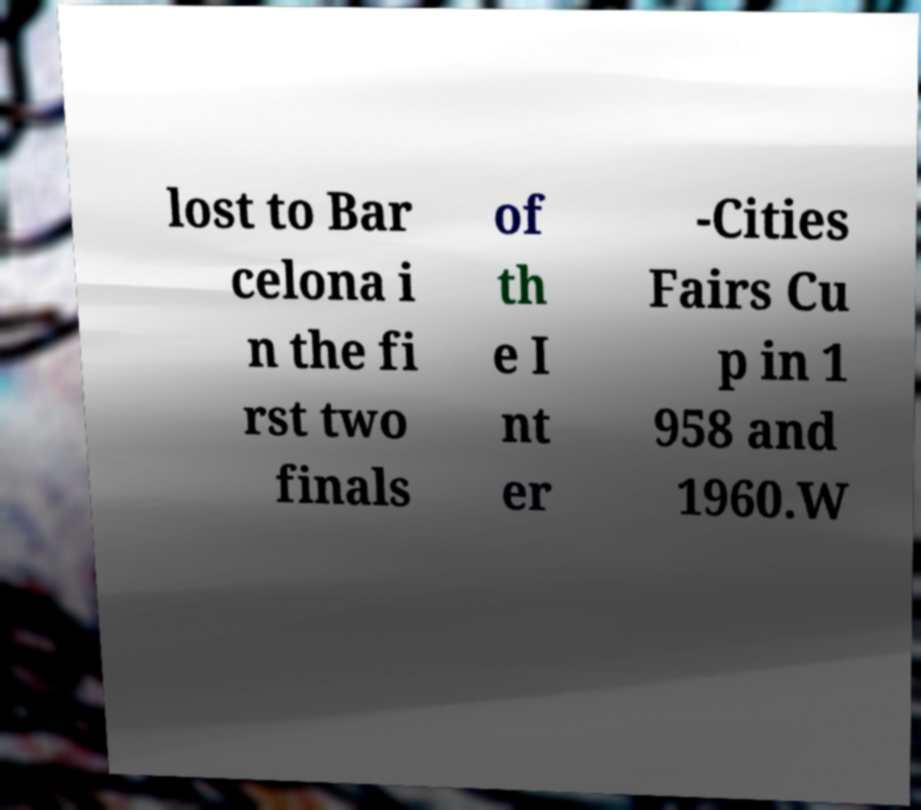Could you extract and type out the text from this image? lost to Bar celona i n the fi rst two finals of th e I nt er -Cities Fairs Cu p in 1 958 and 1960.W 